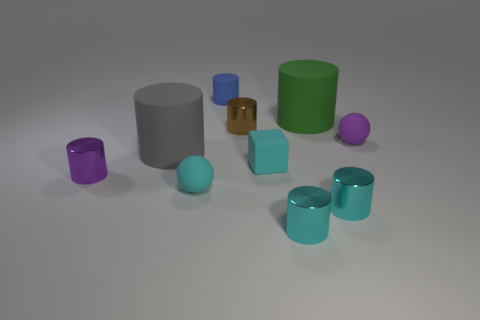Subtract all small cylinders. How many cylinders are left? 2 Subtract all green cylinders. How many cylinders are left? 6 Subtract all blocks. How many objects are left? 9 Subtract 2 balls. How many balls are left? 0 Subtract all purple cylinders. Subtract all red blocks. How many cylinders are left? 6 Subtract all green cylinders. How many yellow blocks are left? 0 Add 2 large green things. How many large green things are left? 3 Add 10 metal blocks. How many metal blocks exist? 10 Subtract 1 green cylinders. How many objects are left? 9 Subtract all cyan matte balls. Subtract all big green matte cylinders. How many objects are left? 8 